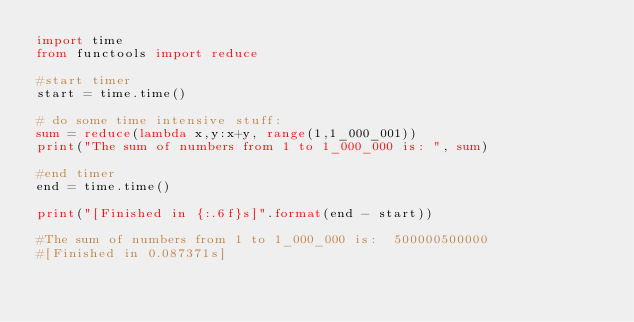Convert code to text. <code><loc_0><loc_0><loc_500><loc_500><_Python_>import time
from functools import reduce

#start timer
start = time.time()

# do some time intensive stuff:
sum = reduce(lambda x,y:x+y, range(1,1_000_001))
print("The sum of numbers from 1 to 1_000_000 is: ", sum)

#end timer
end = time.time()

print("[Finished in {:.6f}s]".format(end - start))

#The sum of numbers from 1 to 1_000_000 is:  500000500000
#[Finished in 0.087371s]
</code> 